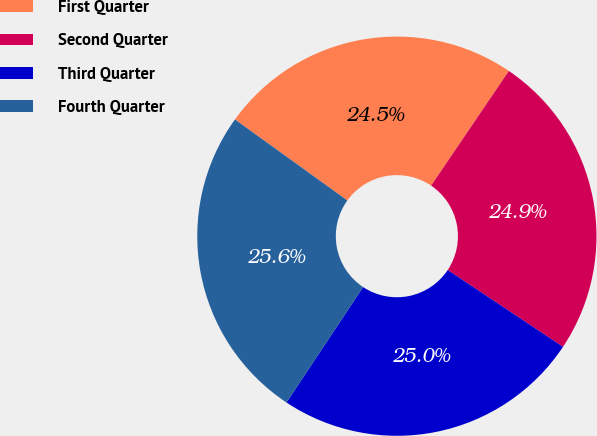<chart> <loc_0><loc_0><loc_500><loc_500><pie_chart><fcel>First Quarter<fcel>Second Quarter<fcel>Third Quarter<fcel>Fourth Quarter<nl><fcel>24.54%<fcel>24.87%<fcel>24.98%<fcel>25.61%<nl></chart> 